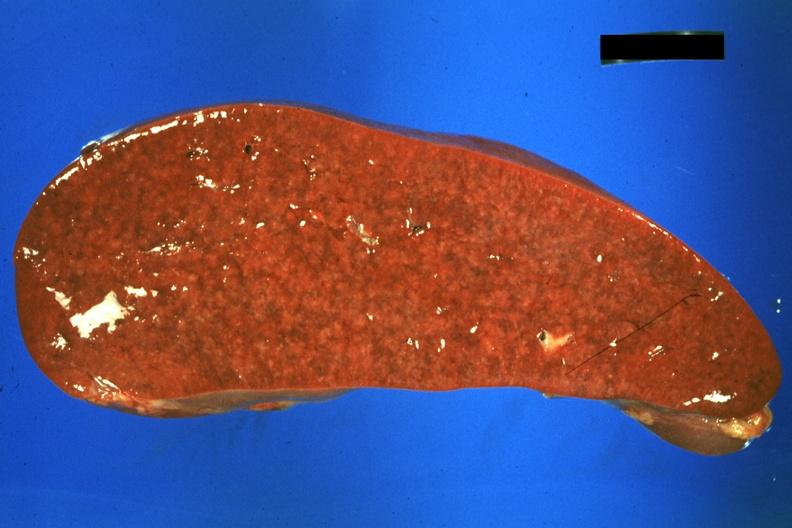what does this image show?
Answer the question using a single word or phrase. Cut surface 